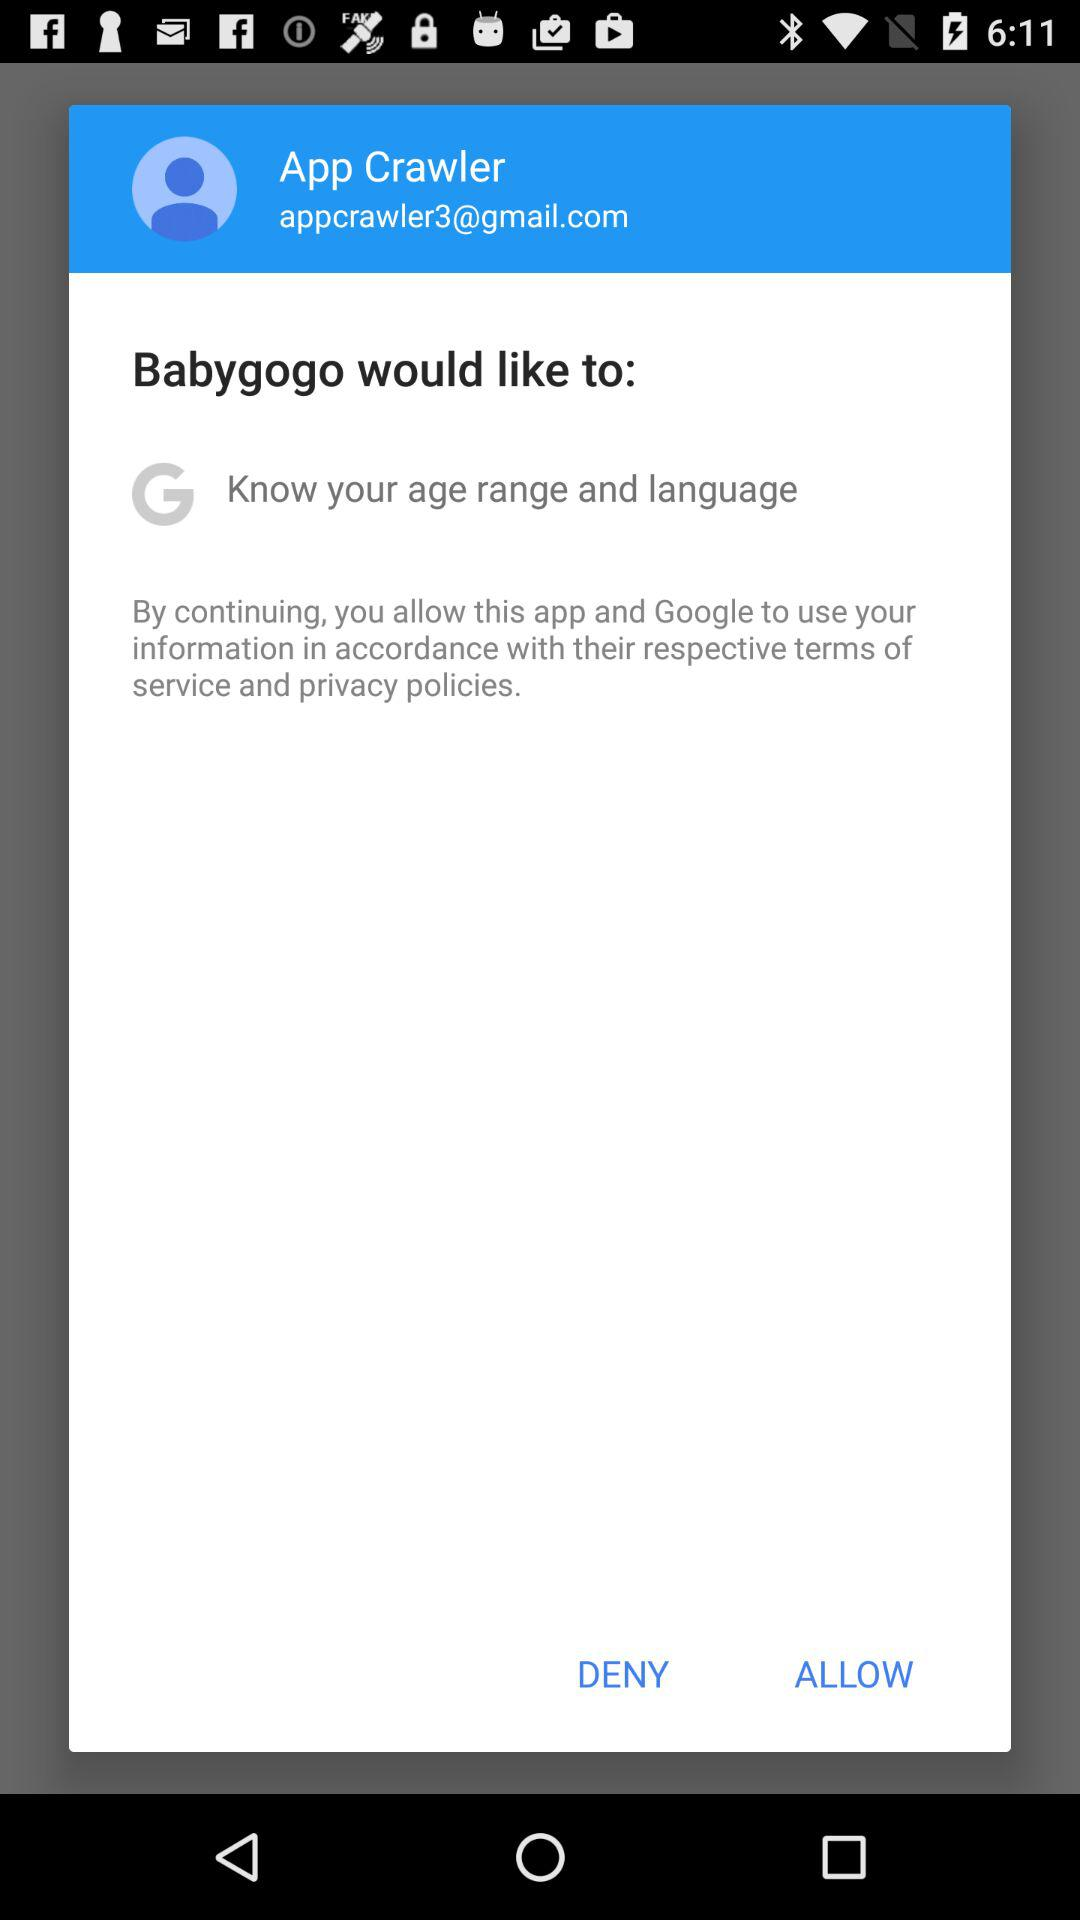How many information does Babygogo want to access?
Answer the question using a single word or phrase. 2 